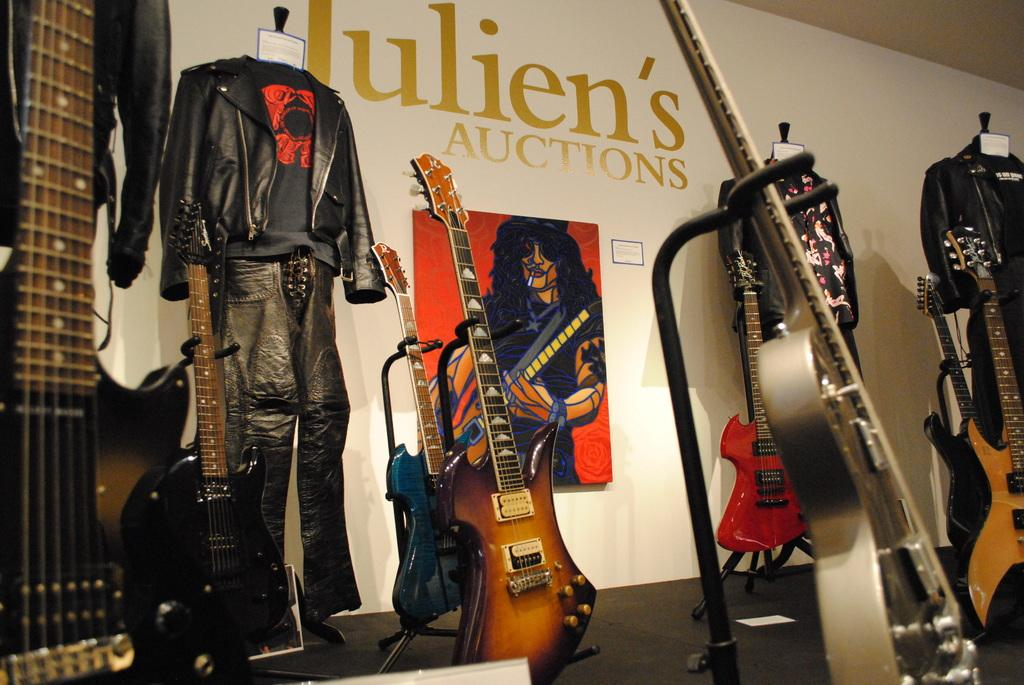What musical instruments are at the bottom of the image? There are guitars at the bottom of the image. What type of items can be seen in the top left side of the image? There are clothes in the top left side of the image. What is on the wall in the top right side of the image? There is a poster on a wall in the top right side of the image. Where is the sink located in the image? There is no sink present in the image. What type of whip is being used in the image? There is no whip present in the image. 